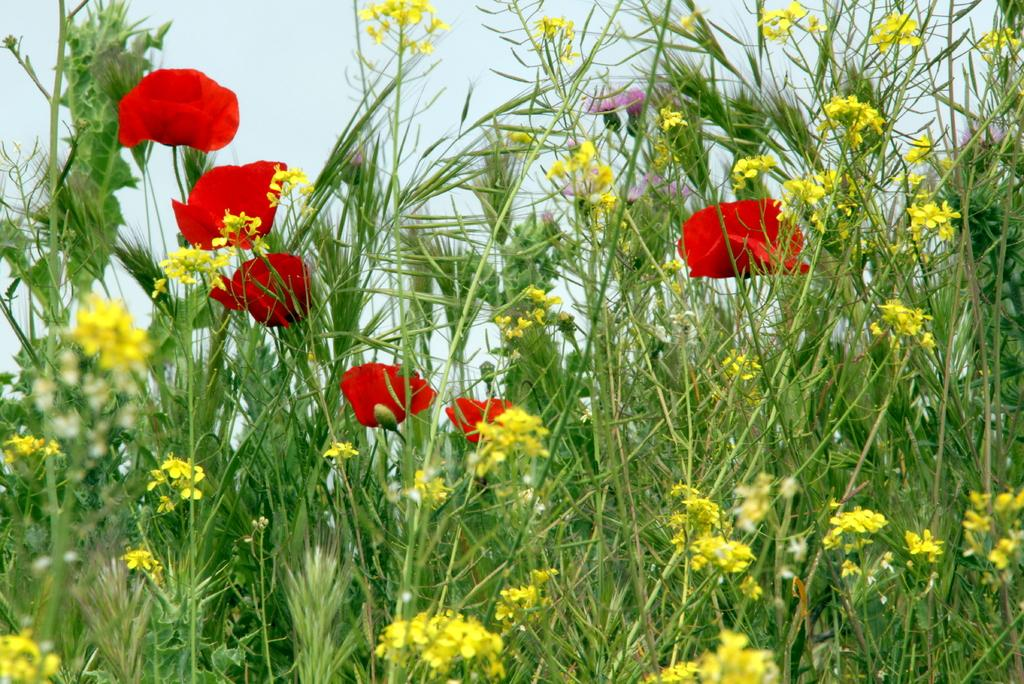What is located in the front of the image? There are flowers in the front of the image. What can be seen in the background of the image? The sky is visible in the background of the image. How many spiders are crawling on the coat in the image? There is no coat or spiders present in the image; it features flowers and the sky. What page is the image taken from? The image is not taken from a page, as it is a standalone photograph. 